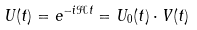<formula> <loc_0><loc_0><loc_500><loc_500>U ( t ) = e ^ { - i \mathcal { H } t } = U _ { 0 } ( t ) \cdot V ( t )</formula> 